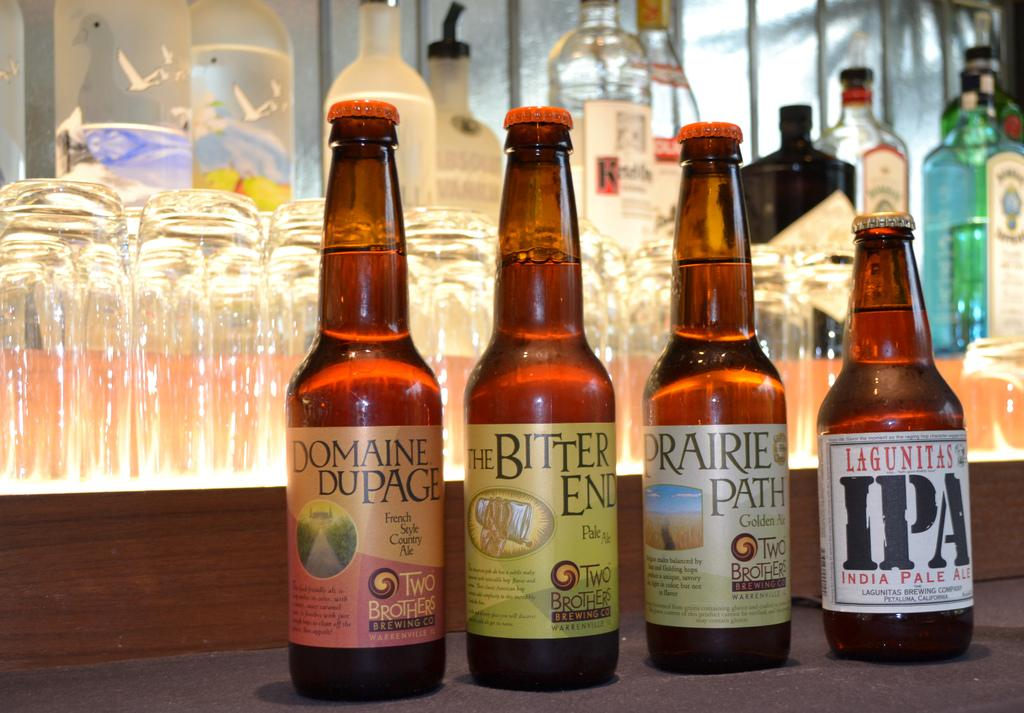<image>
Relay a brief, clear account of the picture shown. Four bottles of beer, one of which is labelled IPA 